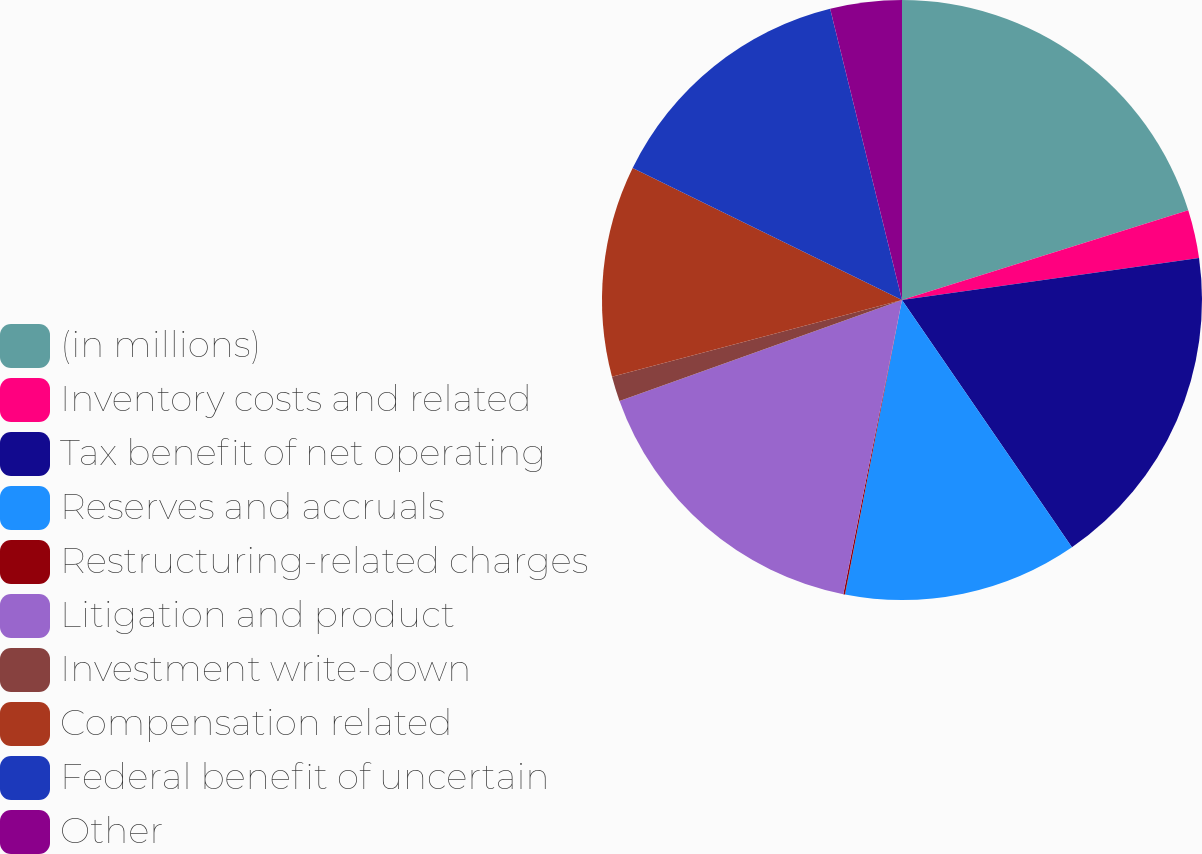Convert chart to OTSL. <chart><loc_0><loc_0><loc_500><loc_500><pie_chart><fcel>(in millions)<fcel>Inventory costs and related<fcel>Tax benefit of net operating<fcel>Reserves and accruals<fcel>Restructuring-related charges<fcel>Litigation and product<fcel>Investment write-down<fcel>Compensation related<fcel>Federal benefit of uncertain<fcel>Other<nl><fcel>20.16%<fcel>2.6%<fcel>17.65%<fcel>12.63%<fcel>0.09%<fcel>16.4%<fcel>1.34%<fcel>11.38%<fcel>13.89%<fcel>3.85%<nl></chart> 